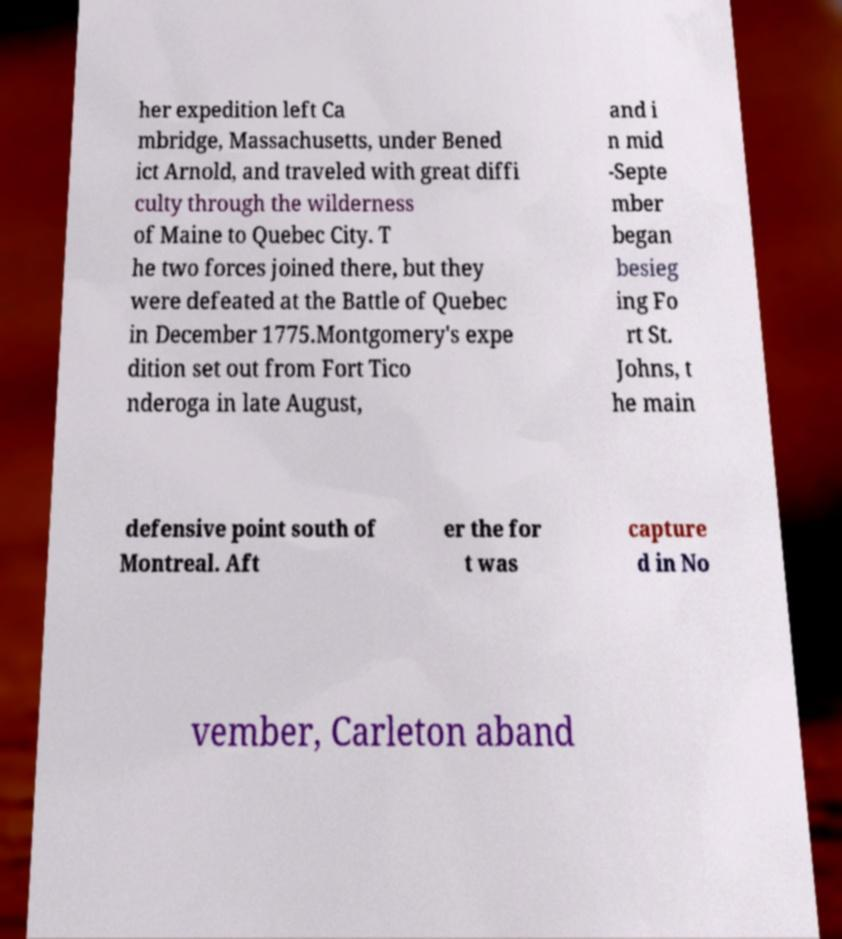Can you read and provide the text displayed in the image?This photo seems to have some interesting text. Can you extract and type it out for me? her expedition left Ca mbridge, Massachusetts, under Bened ict Arnold, and traveled with great diffi culty through the wilderness of Maine to Quebec City. T he two forces joined there, but they were defeated at the Battle of Quebec in December 1775.Montgomery's expe dition set out from Fort Tico nderoga in late August, and i n mid -Septe mber began besieg ing Fo rt St. Johns, t he main defensive point south of Montreal. Aft er the for t was capture d in No vember, Carleton aband 